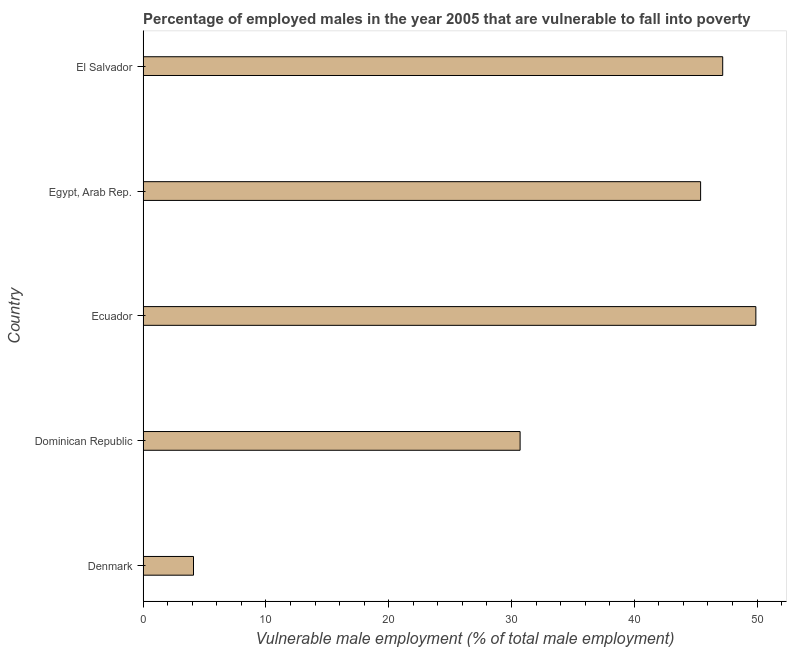Does the graph contain any zero values?
Provide a succinct answer. No. What is the title of the graph?
Your answer should be very brief. Percentage of employed males in the year 2005 that are vulnerable to fall into poverty. What is the label or title of the X-axis?
Make the answer very short. Vulnerable male employment (% of total male employment). What is the percentage of employed males who are vulnerable to fall into poverty in Dominican Republic?
Your answer should be compact. 30.7. Across all countries, what is the maximum percentage of employed males who are vulnerable to fall into poverty?
Offer a terse response. 49.9. Across all countries, what is the minimum percentage of employed males who are vulnerable to fall into poverty?
Keep it short and to the point. 4.1. In which country was the percentage of employed males who are vulnerable to fall into poverty maximum?
Provide a succinct answer. Ecuador. What is the sum of the percentage of employed males who are vulnerable to fall into poverty?
Offer a terse response. 177.3. What is the difference between the percentage of employed males who are vulnerable to fall into poverty in Dominican Republic and El Salvador?
Offer a terse response. -16.5. What is the average percentage of employed males who are vulnerable to fall into poverty per country?
Ensure brevity in your answer.  35.46. What is the median percentage of employed males who are vulnerable to fall into poverty?
Give a very brief answer. 45.4. In how many countries, is the percentage of employed males who are vulnerable to fall into poverty greater than 26 %?
Offer a very short reply. 4. What is the ratio of the percentage of employed males who are vulnerable to fall into poverty in Dominican Republic to that in Ecuador?
Give a very brief answer. 0.61. Is the difference between the percentage of employed males who are vulnerable to fall into poverty in Denmark and Ecuador greater than the difference between any two countries?
Your response must be concise. Yes. What is the difference between the highest and the lowest percentage of employed males who are vulnerable to fall into poverty?
Give a very brief answer. 45.8. How many bars are there?
Ensure brevity in your answer.  5. Are all the bars in the graph horizontal?
Offer a very short reply. Yes. What is the difference between two consecutive major ticks on the X-axis?
Provide a short and direct response. 10. Are the values on the major ticks of X-axis written in scientific E-notation?
Your answer should be very brief. No. What is the Vulnerable male employment (% of total male employment) of Denmark?
Offer a terse response. 4.1. What is the Vulnerable male employment (% of total male employment) in Dominican Republic?
Make the answer very short. 30.7. What is the Vulnerable male employment (% of total male employment) of Ecuador?
Your answer should be compact. 49.9. What is the Vulnerable male employment (% of total male employment) in Egypt, Arab Rep.?
Provide a succinct answer. 45.4. What is the Vulnerable male employment (% of total male employment) in El Salvador?
Keep it short and to the point. 47.2. What is the difference between the Vulnerable male employment (% of total male employment) in Denmark and Dominican Republic?
Make the answer very short. -26.6. What is the difference between the Vulnerable male employment (% of total male employment) in Denmark and Ecuador?
Make the answer very short. -45.8. What is the difference between the Vulnerable male employment (% of total male employment) in Denmark and Egypt, Arab Rep.?
Ensure brevity in your answer.  -41.3. What is the difference between the Vulnerable male employment (% of total male employment) in Denmark and El Salvador?
Offer a terse response. -43.1. What is the difference between the Vulnerable male employment (% of total male employment) in Dominican Republic and Ecuador?
Give a very brief answer. -19.2. What is the difference between the Vulnerable male employment (% of total male employment) in Dominican Republic and Egypt, Arab Rep.?
Keep it short and to the point. -14.7. What is the difference between the Vulnerable male employment (% of total male employment) in Dominican Republic and El Salvador?
Provide a succinct answer. -16.5. What is the ratio of the Vulnerable male employment (% of total male employment) in Denmark to that in Dominican Republic?
Give a very brief answer. 0.13. What is the ratio of the Vulnerable male employment (% of total male employment) in Denmark to that in Ecuador?
Your response must be concise. 0.08. What is the ratio of the Vulnerable male employment (% of total male employment) in Denmark to that in Egypt, Arab Rep.?
Offer a terse response. 0.09. What is the ratio of the Vulnerable male employment (% of total male employment) in Denmark to that in El Salvador?
Your answer should be compact. 0.09. What is the ratio of the Vulnerable male employment (% of total male employment) in Dominican Republic to that in Ecuador?
Your answer should be compact. 0.61. What is the ratio of the Vulnerable male employment (% of total male employment) in Dominican Republic to that in Egypt, Arab Rep.?
Provide a succinct answer. 0.68. What is the ratio of the Vulnerable male employment (% of total male employment) in Dominican Republic to that in El Salvador?
Provide a short and direct response. 0.65. What is the ratio of the Vulnerable male employment (% of total male employment) in Ecuador to that in Egypt, Arab Rep.?
Make the answer very short. 1.1. What is the ratio of the Vulnerable male employment (% of total male employment) in Ecuador to that in El Salvador?
Make the answer very short. 1.06. What is the ratio of the Vulnerable male employment (% of total male employment) in Egypt, Arab Rep. to that in El Salvador?
Your answer should be compact. 0.96. 